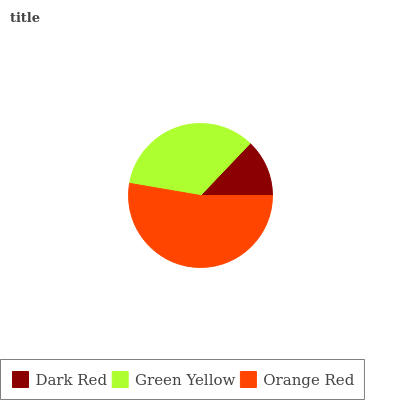Is Dark Red the minimum?
Answer yes or no. Yes. Is Orange Red the maximum?
Answer yes or no. Yes. Is Green Yellow the minimum?
Answer yes or no. No. Is Green Yellow the maximum?
Answer yes or no. No. Is Green Yellow greater than Dark Red?
Answer yes or no. Yes. Is Dark Red less than Green Yellow?
Answer yes or no. Yes. Is Dark Red greater than Green Yellow?
Answer yes or no. No. Is Green Yellow less than Dark Red?
Answer yes or no. No. Is Green Yellow the high median?
Answer yes or no. Yes. Is Green Yellow the low median?
Answer yes or no. Yes. Is Dark Red the high median?
Answer yes or no. No. Is Dark Red the low median?
Answer yes or no. No. 